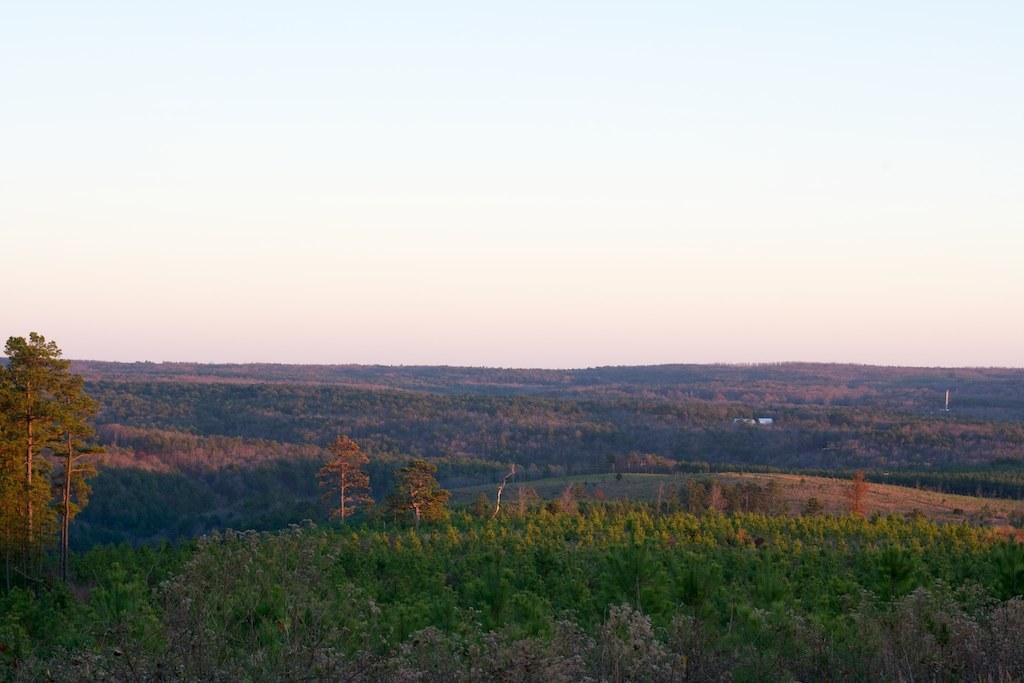In one or two sentences, can you explain what this image depicts? At the bottom of the image, we can see so many trees and plants. Background we can see the sky. 